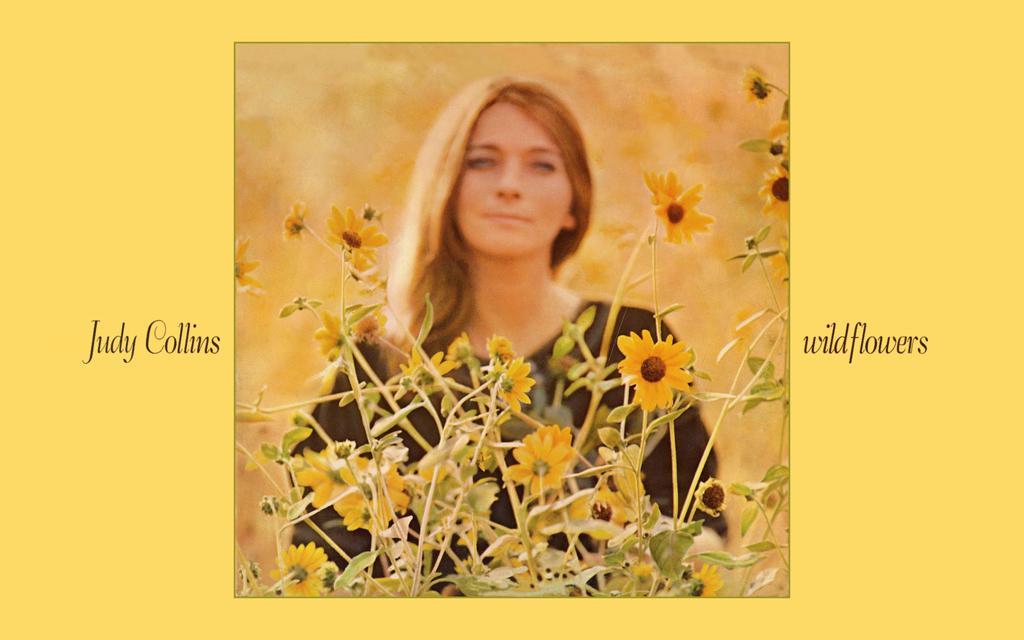How would you summarize this image in a sentence or two? There is a yellow color poster having an image and texts. In the image, there is a woman in a black color dress. In front of her, there are plants having yellow color flowers. And the background of this image is blurred. 